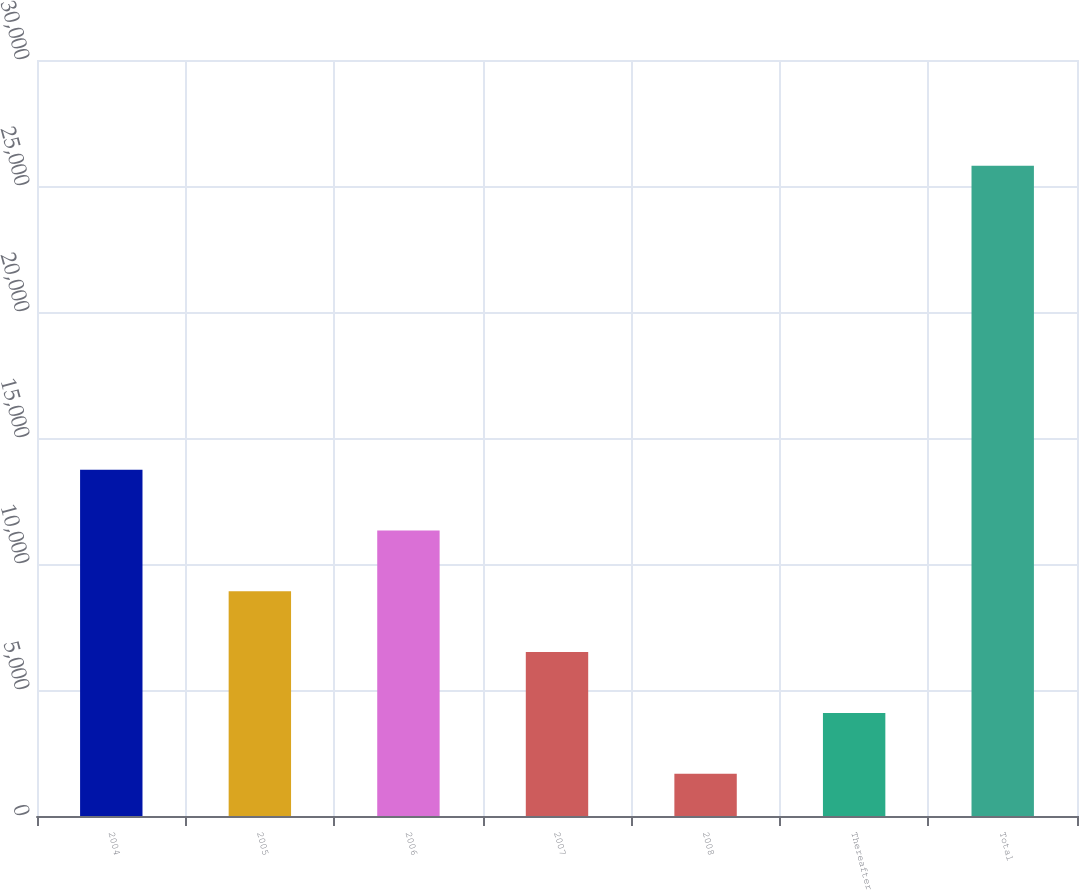Convert chart. <chart><loc_0><loc_0><loc_500><loc_500><bar_chart><fcel>2004<fcel>2005<fcel>2006<fcel>2007<fcel>2008<fcel>Thereafter<fcel>Total<nl><fcel>13741<fcel>8915.8<fcel>11328.4<fcel>6503.2<fcel>1678<fcel>4090.6<fcel>25804<nl></chart> 